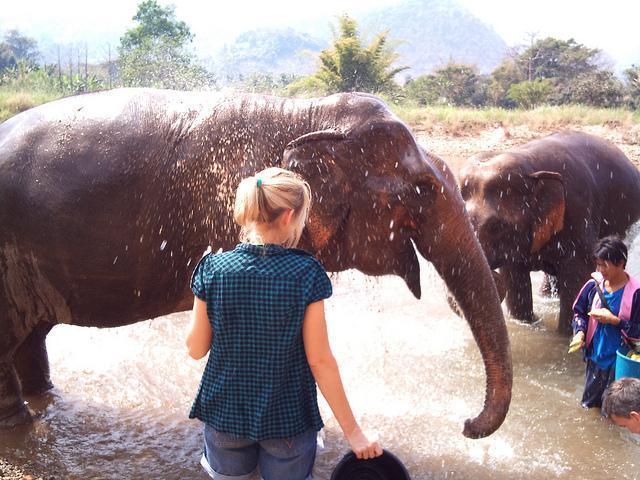How many elephants are there?
Give a very brief answer. 2. How many heads are visible here?
Give a very brief answer. 4. How many people are visible?
Give a very brief answer. 2. How many elephants can you see?
Give a very brief answer. 2. How many horses are there?
Give a very brief answer. 0. 